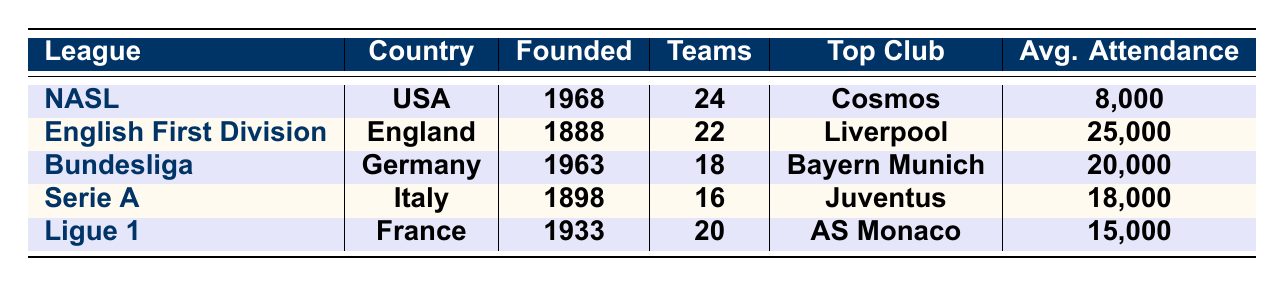What is the average attendance for the NASL? The table lists the average attendance for the NASL as 8,000.
Answer: 8,000 Which league was founded first? The English Football League First Division was founded in 1888, making it the oldest league in the table.
Answer: English Football League First Division How many teams are there in the Serie A? The table indicates that Serie A has a total of 16 teams.
Answer: 16 Which league has a higher average attendance: Bundesliga or Ligue 1? The average attendance for Bundesliga is 20,000, while Ligue 1 has 15,000, so Bundesliga has a higher average attendance.
Answer: Bundesliga Which league's top club is Juventus? The table specifies that Serie A is the league where Juventus is the top club.
Answer: Serie A Is the average attendance for the English First Division higher than that of Ligue 1? Yes, the English First Division has an average attendance of 25,000, which is higher than Ligue 1's 15,000.
Answer: Yes What is the total number of teams in all the leagues listed? Adding the number of teams: NASL (24) + English First Division (22) + Bundesliga (18) + Serie A (16) + Ligue 1 (20) gives a total of 100 teams.
Answer: 100 What is the difference in average attendance between Bundesliga and Serie A? The average attendance for Bundesliga is 20,000 and for Serie A is 18,000, so the difference is 20,000 - 18,000 = 2,000.
Answer: 2,000 Which league has the least number of teams? Serie A has the least number of teams at 16.
Answer: Serie A True or False: Pelé played in the English First Division. The table shows that Pelé is listed as a famous player for NASL, not in the English First Division, so this statement is false.
Answer: False List the top clubs in the two leagues founded in the 1960s. The leagues founded in the 1960s are NASL (top club: Cosmos) and Bundesliga (top club: FC Bayern Munich). The top clubs are Cosmos and FC Bayern Munich.
Answer: Cosmos and FC Bayern Munich 